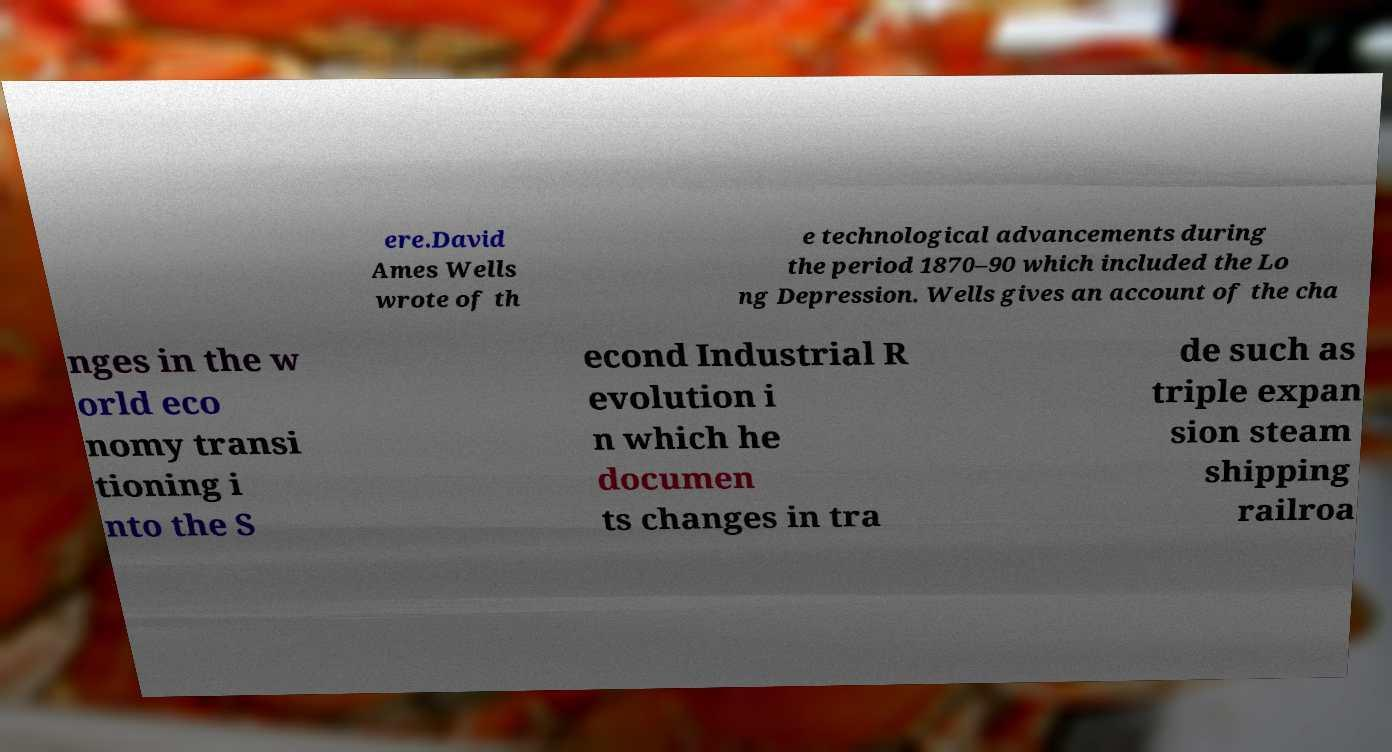Can you read and provide the text displayed in the image?This photo seems to have some interesting text. Can you extract and type it out for me? ere.David Ames Wells wrote of th e technological advancements during the period 1870–90 which included the Lo ng Depression. Wells gives an account of the cha nges in the w orld eco nomy transi tioning i nto the S econd Industrial R evolution i n which he documen ts changes in tra de such as triple expan sion steam shipping railroa 